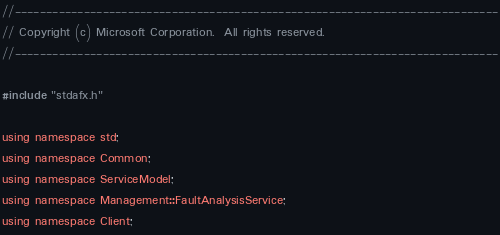Convert code to text. <code><loc_0><loc_0><loc_500><loc_500><_C++_>//-----------------------------------------------------------------------------
// Copyright (c) Microsoft Corporation.  All rights reserved.
//-----------------------------------------------------------------------------

#include "stdafx.h"

using namespace std;
using namespace Common;
using namespace ServiceModel;
using namespace Management::FaultAnalysisService;
using namespace Client;
</code> 